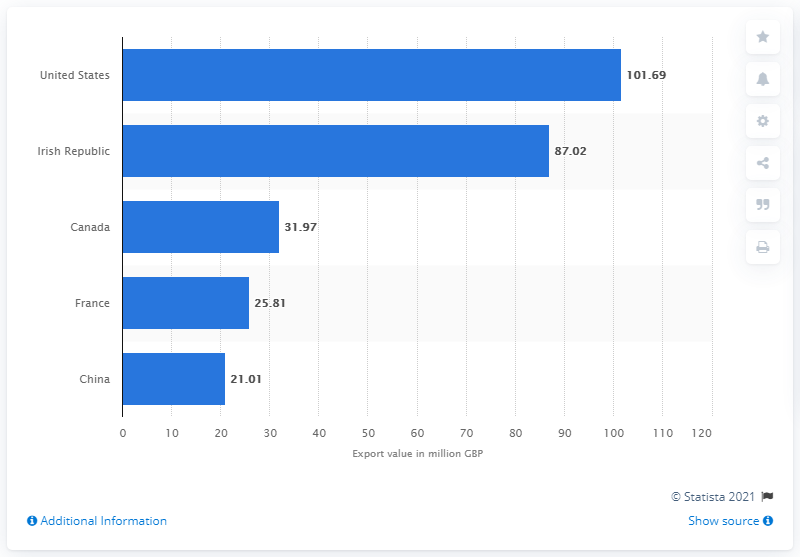Indicate a few pertinent items in this graphic. The value of beer exports from the UK was 101.69 million. The beer exports from the Irish Republic are worth 87.02 million. 